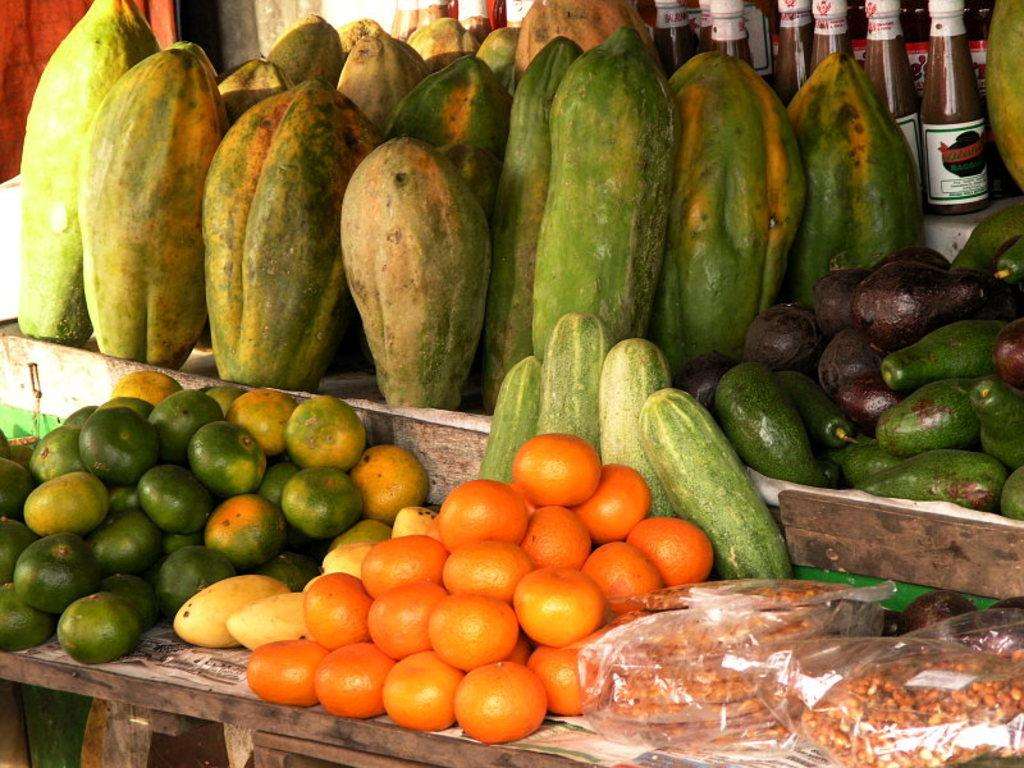What is the main piece of furniture in the image? There is a table in the image. What types of fruits are on the table? There are oranges, papayas, and an avocado on the table. What else can be seen on the table besides fruits? There are bottles and a cucumber on the table. How are the items on the table protected or covered? There are covers placed on the table. What type of whistle can be heard coming from the door in the image? There is no whistle or door present in the image; it only features a table with various items on it. 